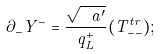<formula> <loc_0><loc_0><loc_500><loc_500>\partial _ { - } Y ^ { - } = \frac { \sqrt { \ a ^ { \prime } } } { q ^ { + } _ { L } } ( T ^ { t r } _ { - - } ) ;</formula> 